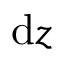Convert formula to latex. <formula><loc_0><loc_0><loc_500><loc_500>d z</formula> 